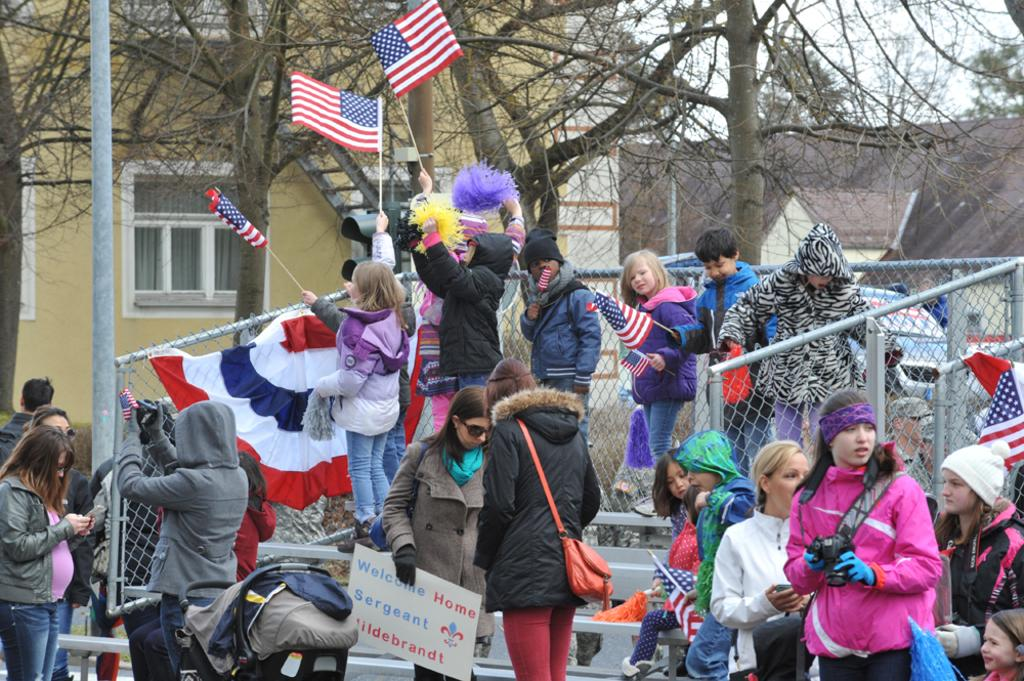How many people are in the image? There are people in the image, but the exact number is not specified. What are some people doing in the image? Some people are holding flags in the image. What can be seen in the background of the image? There is a building, houses, and trees in the background of the image. Can you see any eggs on the seashore in the image? There is no seashore or eggs present in the image. 